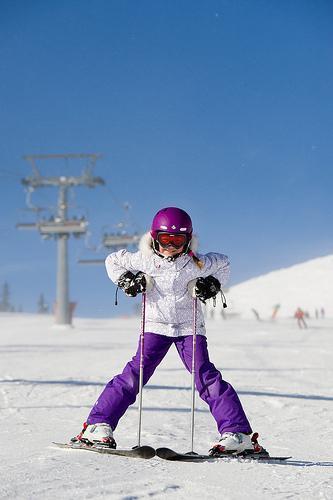How many kids are there?
Give a very brief answer. 1. 